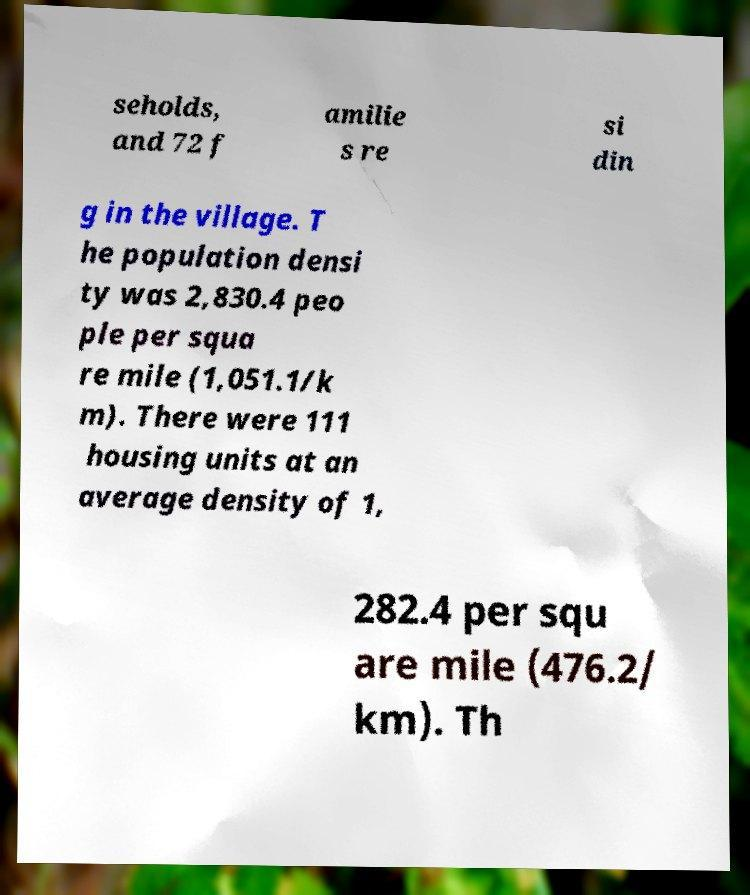Please read and relay the text visible in this image. What does it say? seholds, and 72 f amilie s re si din g in the village. T he population densi ty was 2,830.4 peo ple per squa re mile (1,051.1/k m). There were 111 housing units at an average density of 1, 282.4 per squ are mile (476.2/ km). Th 